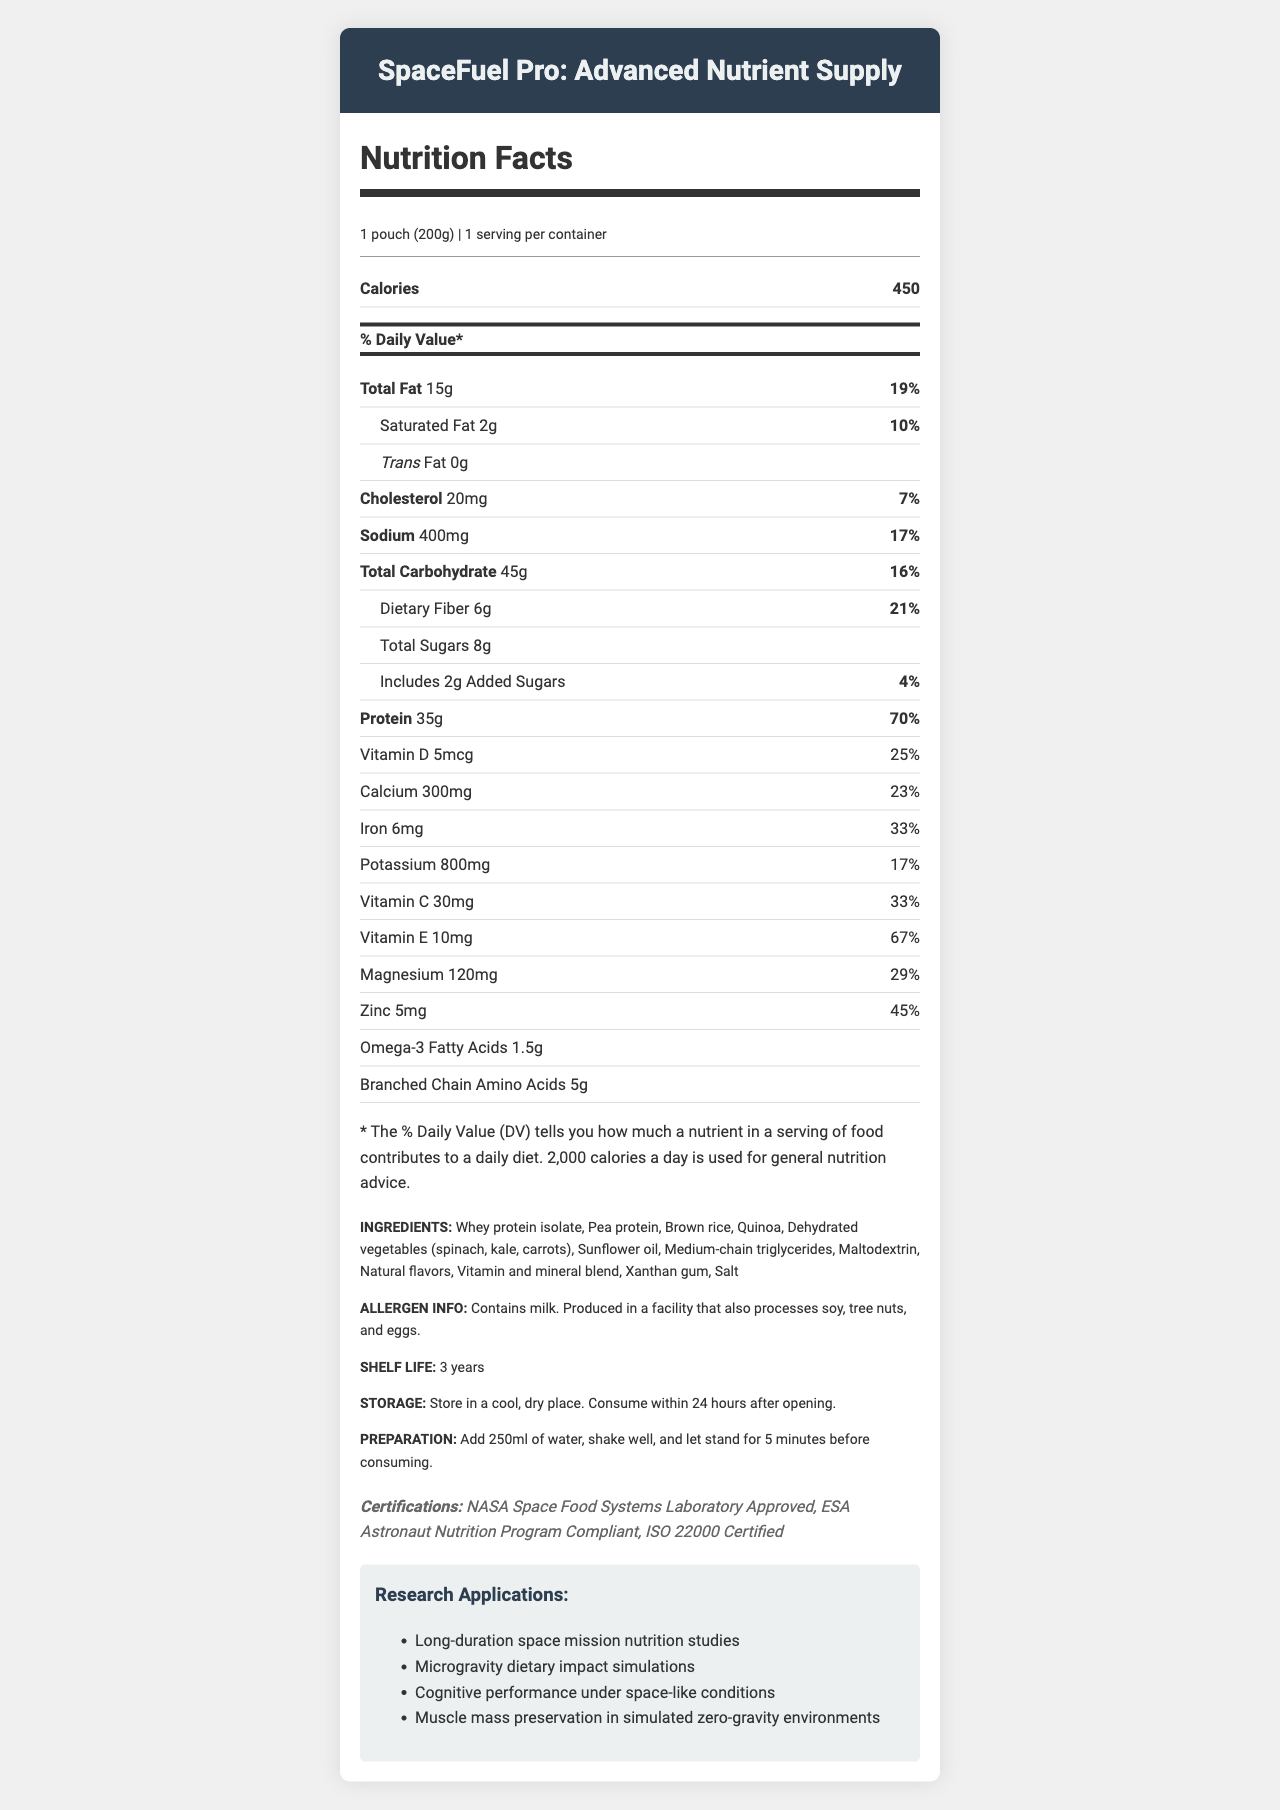what is the serving size? The serving size is listed at the beginning of the Nutrition Facts section, denoting "1 pouch (200g)".
Answer: 1 pouch (200g) how many calories are in one serving? The calories per serving is mentioned right after the serving size with a value of 450.
Answer: 450 what is the total fat content in percentage? The % Daily Value of total fat is listed as 19% next to the total fat amount of 15g.
Answer: 19% how much protein is in one pouch of this product? The protein content is listed with a value of 35g and a % Daily Value of 70%.
Answer: 35g what vitamins and minerals have more than 30% daily value? The nutrients with % Daily Value exceeding 30% are listed under their respective categories: Protein, Iron, Vitamin C, Vitamin E, and Zinc.
Answer: Protein (70%), Iron (33%), Vitamin C (33%), Vitamin E (67%), Zinc (45%) what is the shelf life of the product? The shelf life is mentioned under the ingredients section with a specified duration of 3 years.
Answer: 3 years how should the product be stored? Storage instructions are provided, stating the product should be stored in a cool, dry place and consumed within 24 hours after opening.
Answer: Store in a cool, dry place. Consume within 24 hours after opening. what approval certifications does this product have? The certifications are listed towards the end of the document under a dedicated Certifications section.
Answer: NASA Space Food Systems Laboratory Approved, ESA Astronaut Nutrition Program Compliant, ISO 22000 Certified what are the main ingredients used in this product? The ingredients section provides a complete list of the main ingredients used in the product.
Answer: Whey protein isolate, Pea protein, Brown rice, Quinoa, Dehydrated vegetables (spinach, kale, carrots), Sunflower oil, Medium-chain triglycerides, Maltodextrin, Natural flavors, Vitamin and mineral blend, Xanthan gum, Salt does this product contain trans fat? The trans fat value is explicitly mentioned as 0g.
Answer: No to prepare this product, which of the following steps must be taken? 
A. Add 250ml of water, shake well, and let stand for 5 minutes 
B. Add 250ml of milk, shake well, and let stand for 10 minutes 
C. Add 500ml of water, shake well, and let stand for 5 minutes 
D. Add 500ml of milk, shake well, and let stand for 10 minutes The preparation instructions specify to add 250ml of water, shake well, and let stand for 5 minutes before consuming.
Answer: A which statement is true about the Vitamin D content? 
I. One serving contains 5mcg of Vitamin D 
II. One serving provides 25% of the daily value for Vitamin D 
III. One serving contains 5mg of Vitamin D 
IV. One serving provides 30% of the daily value for Vitamin D The document states 5mcg of Vitamin D and a % Daily Value of 25%, making statements I and II true.
Answer: I and II are there more grams of sugars or dietary fiber in the product? The document states there are 6g of dietary fiber and 8g of total sugars, indicating more grams of sugars.
Answer: Dietary fiber is the product compliant with the ESA Astronaut Nutrition Program? The document lists "ESA Astronaut Nutrition Program Compliant" under the certifications section.
Answer: Yes summarize the Nutrition Facts of the product This summary consolidates the main nutrition details, ingredients, certifications, and additional information provided in the document.
Answer: The document provides detailed nutrition information for a protein-rich shelf-stable meal "SpaceFuel Pro: Advanced Nutrient Supply". Each serving (1 pouch) contains 450 calories, 15g total fat (19% DV), 2g saturated fat, 0g trans fat, 20mg cholesterol (7% DV), 400mg sodium (17% DV), 45g total carbohydrates (16% DV), 6g dietary fiber (21% DV), 8g total sugars including 2g added sugars (4% DV), and 35g protein (70% DV). It also lists percentages for various vitamins and minerals, ingredient details, allergen info, shelf life, storage instructions, preparation steps, certifications, and research applications. what is the impact of this product on cognitive performance under space-like conditions? The document does state that the product is used in cognitive performance studies under space-like conditions, but it does not provide specific results or findings from those studies.
Answer: Cannot be determined 